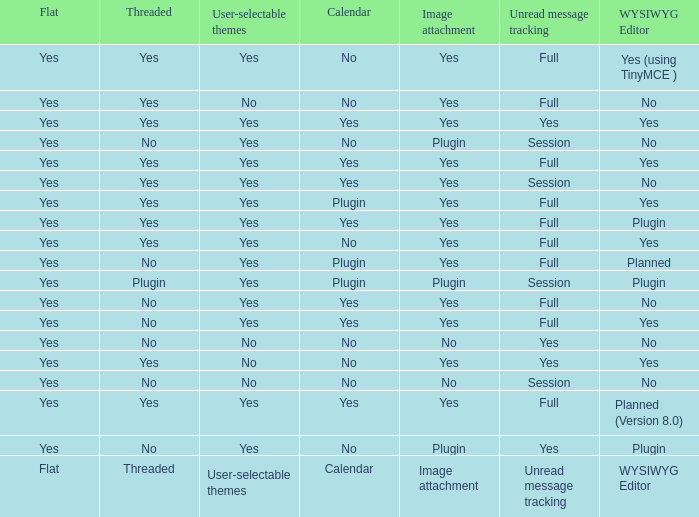Which wysiwyg editor features an image attachment option and a calendar plugin? Yes, Planned. 